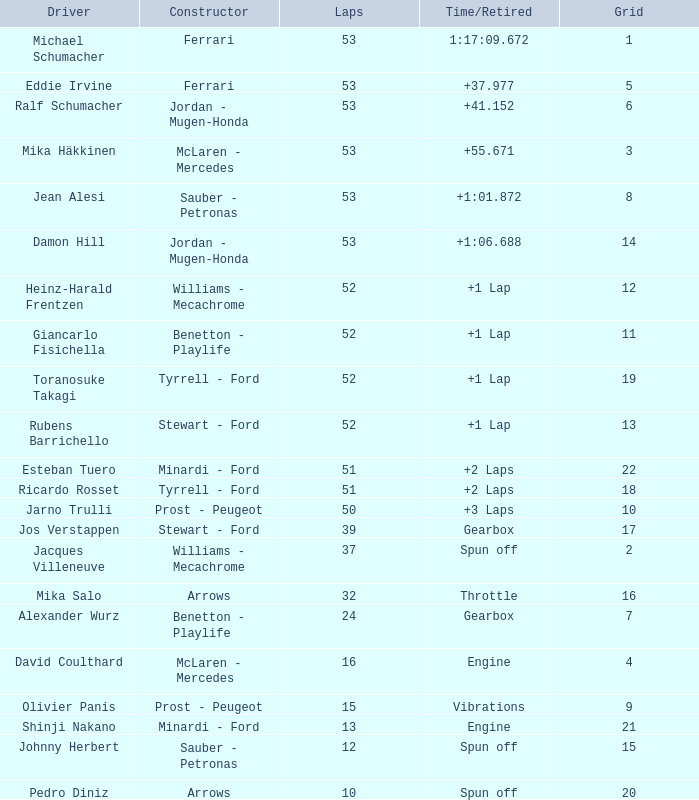What is the high lap total for pedro diniz? 10.0. 